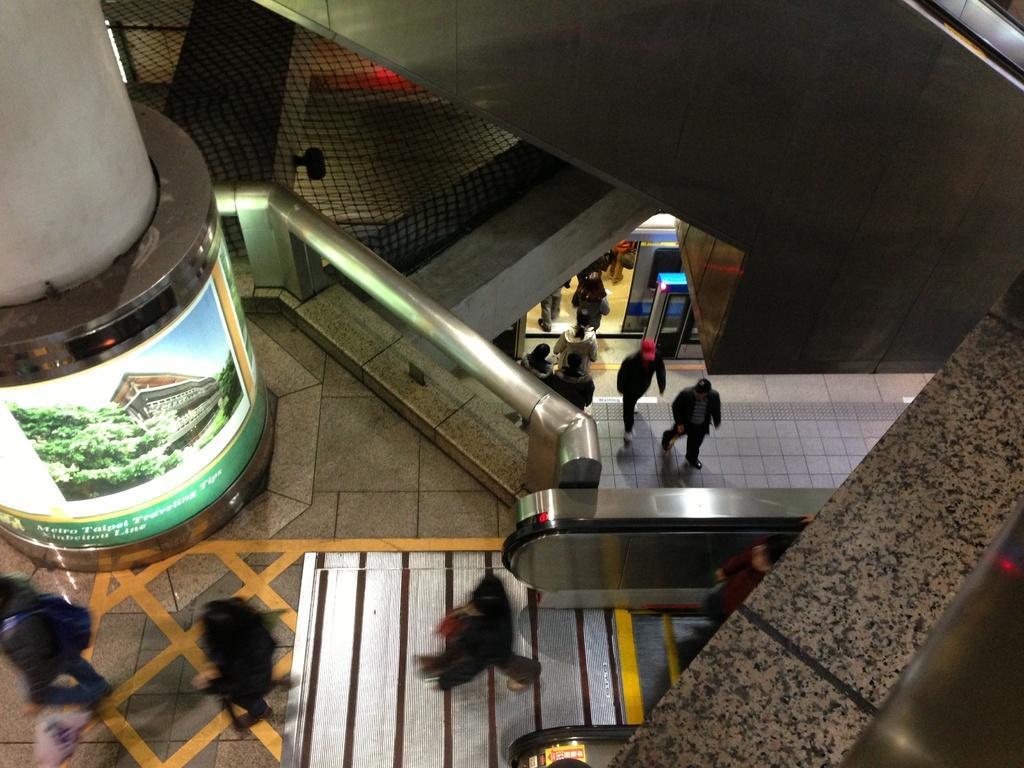Please provide a concise description of this image. In this image I can see a pillar in the top left corner with some screen with some images running. I can see some people walking out from an escalator at the bottom of the image I can see a metal balcony adjacent to the escalator. I can see some people on the ground floor with some electronic devices. At the top of the image I can see a metal escalator or stairs just below that I can see a net. 